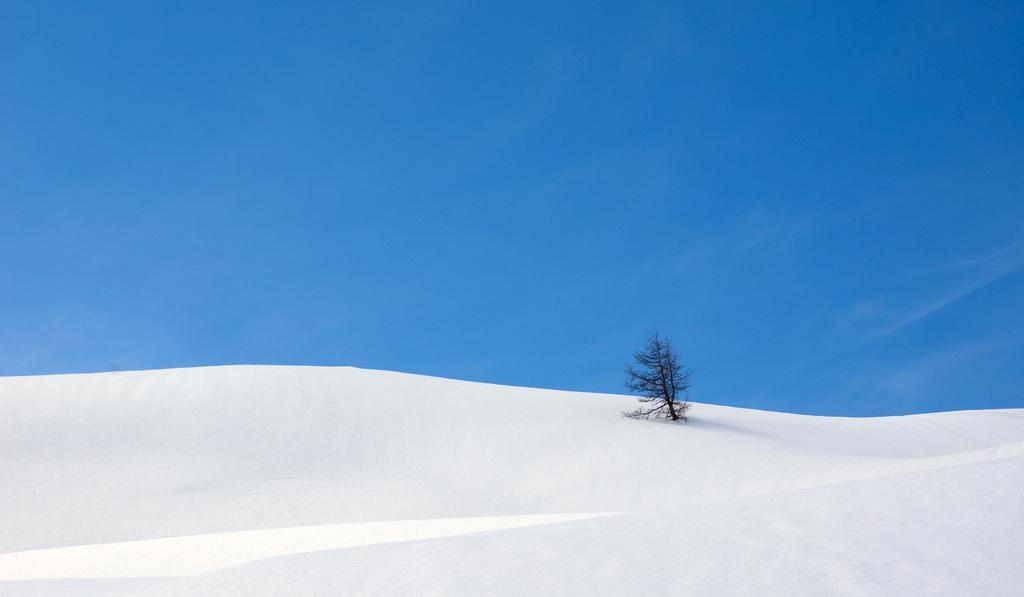Please provide a concise description of this image. This image is taken outdoors. At the top of the image there is a sky. At the bottom of the image there is a snow. In the middle of the image there is a tree. 